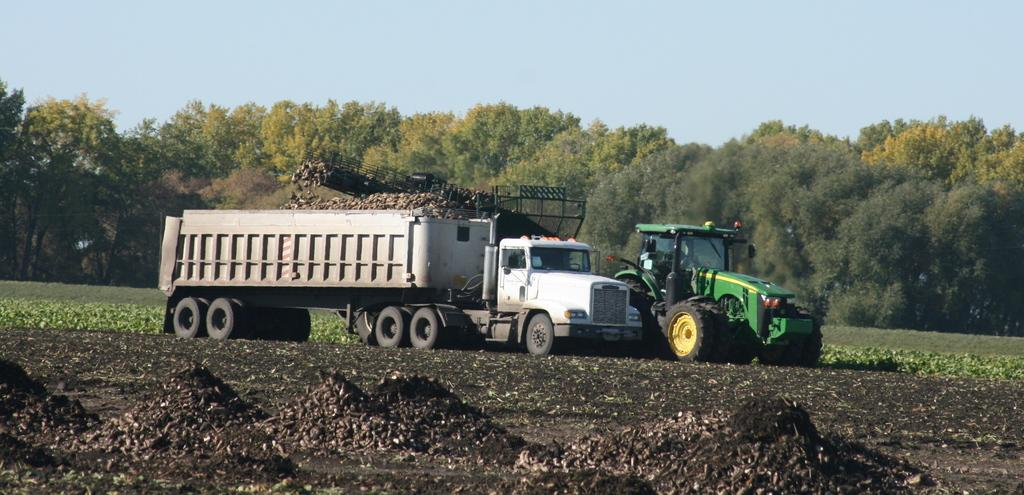What type of vehicles are present in the image? There is a truck and a tractor in the image. What can be seen in the background of the image? Plants, trees, and the sky are visible in the background of the image. What type of cannon is being fired in the image? There is no cannon present in the image. What part of the human body is visible in the image? There are no human body parts visible in the image. 